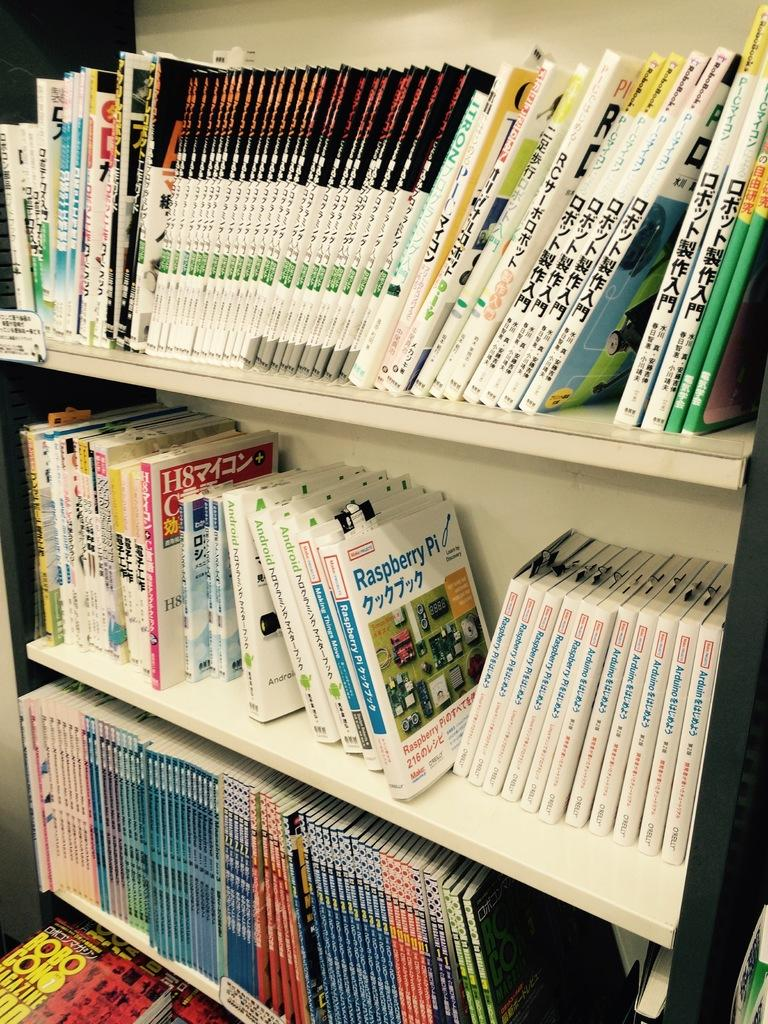<image>
Render a clear and concise summary of the photo. A manual for the Raspberry Pi sits on the shelf with many other manuals. 